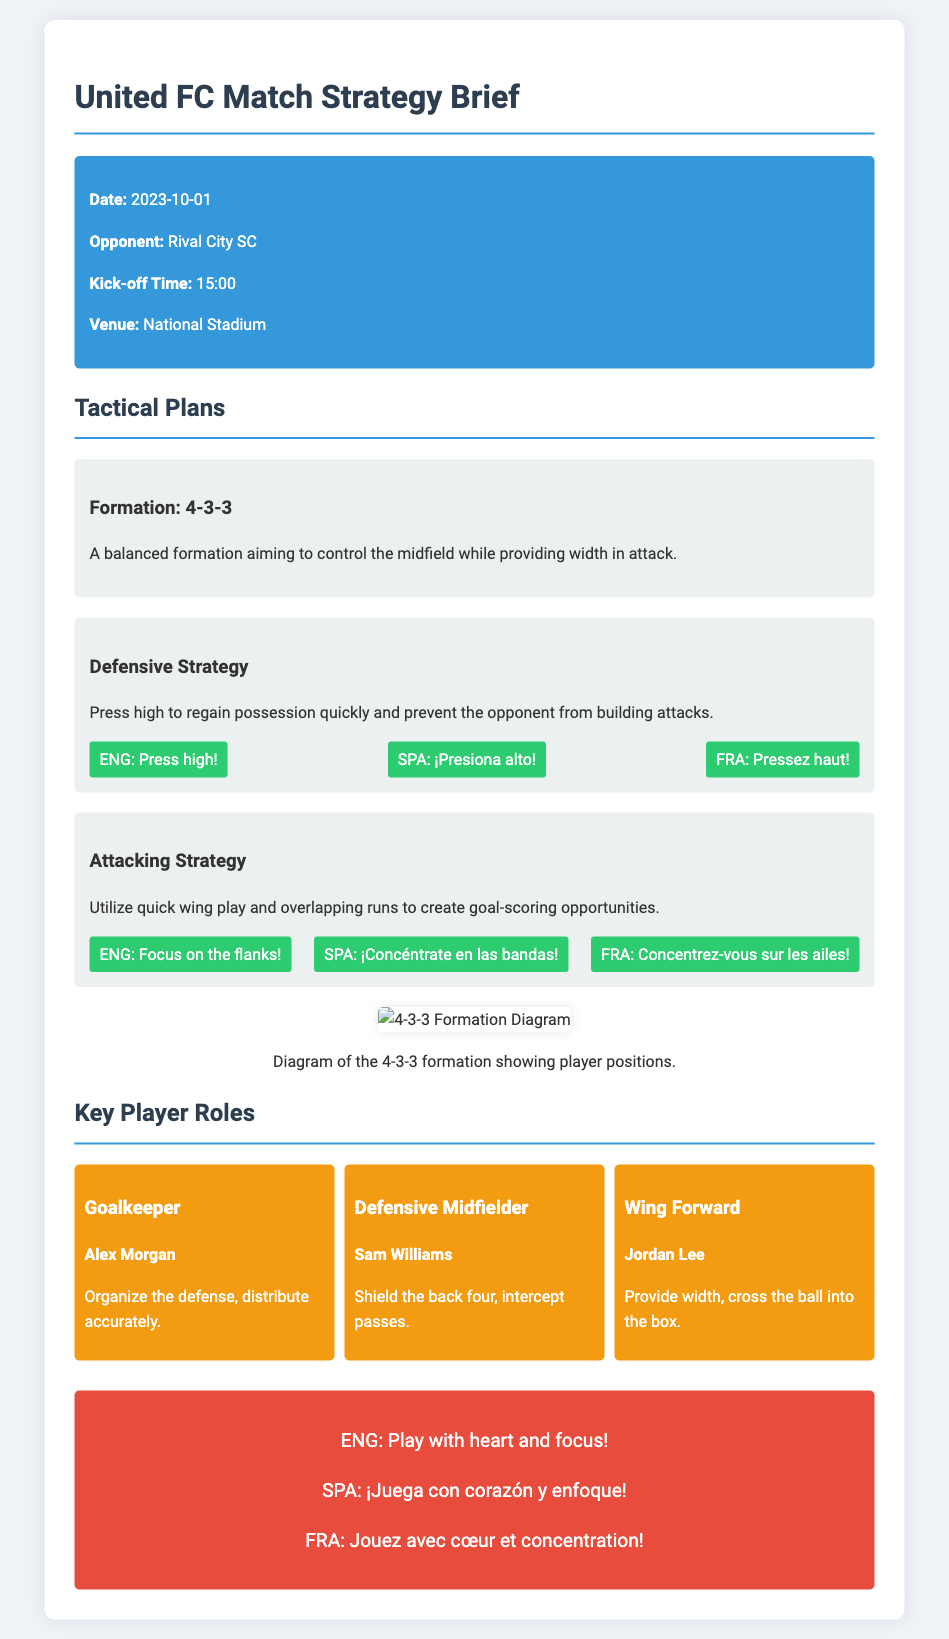What is the date of the match? The date of the match is explicitly stated in the document as "2023-10-01".
Answer: 2023-10-01 Who is the opponent team? The document mentions the opponent team as "Rival City SC".
Answer: Rival City SC What formation is used in the tactical plan? The tactical plan specifies the formation as "4-3-3".
Answer: 4-3-3 What is the main focus of the defensive strategy? The defensive strategy emphasizes pressing high to regain possession quickly.
Answer: Press high Who is the goalkeeper? The document identifies "Alex Morgan" as the goalkeeper.
Answer: Alex Morgan What is the motivational message given to the players? The motivational message encourages players to play with heart and focus.
Answer: Play with heart and focus What role does Sam Williams play? The document states that Sam Williams is the defensive midfielder.
Answer: Defensive Midfielder What is one key phrase for the attacking strategy in Spanish? The document provides the phrase for the attacking strategy in Spanish as "¡Concéntrate en las bandas!".
Answer: ¡Concéntrate en las bandas! 